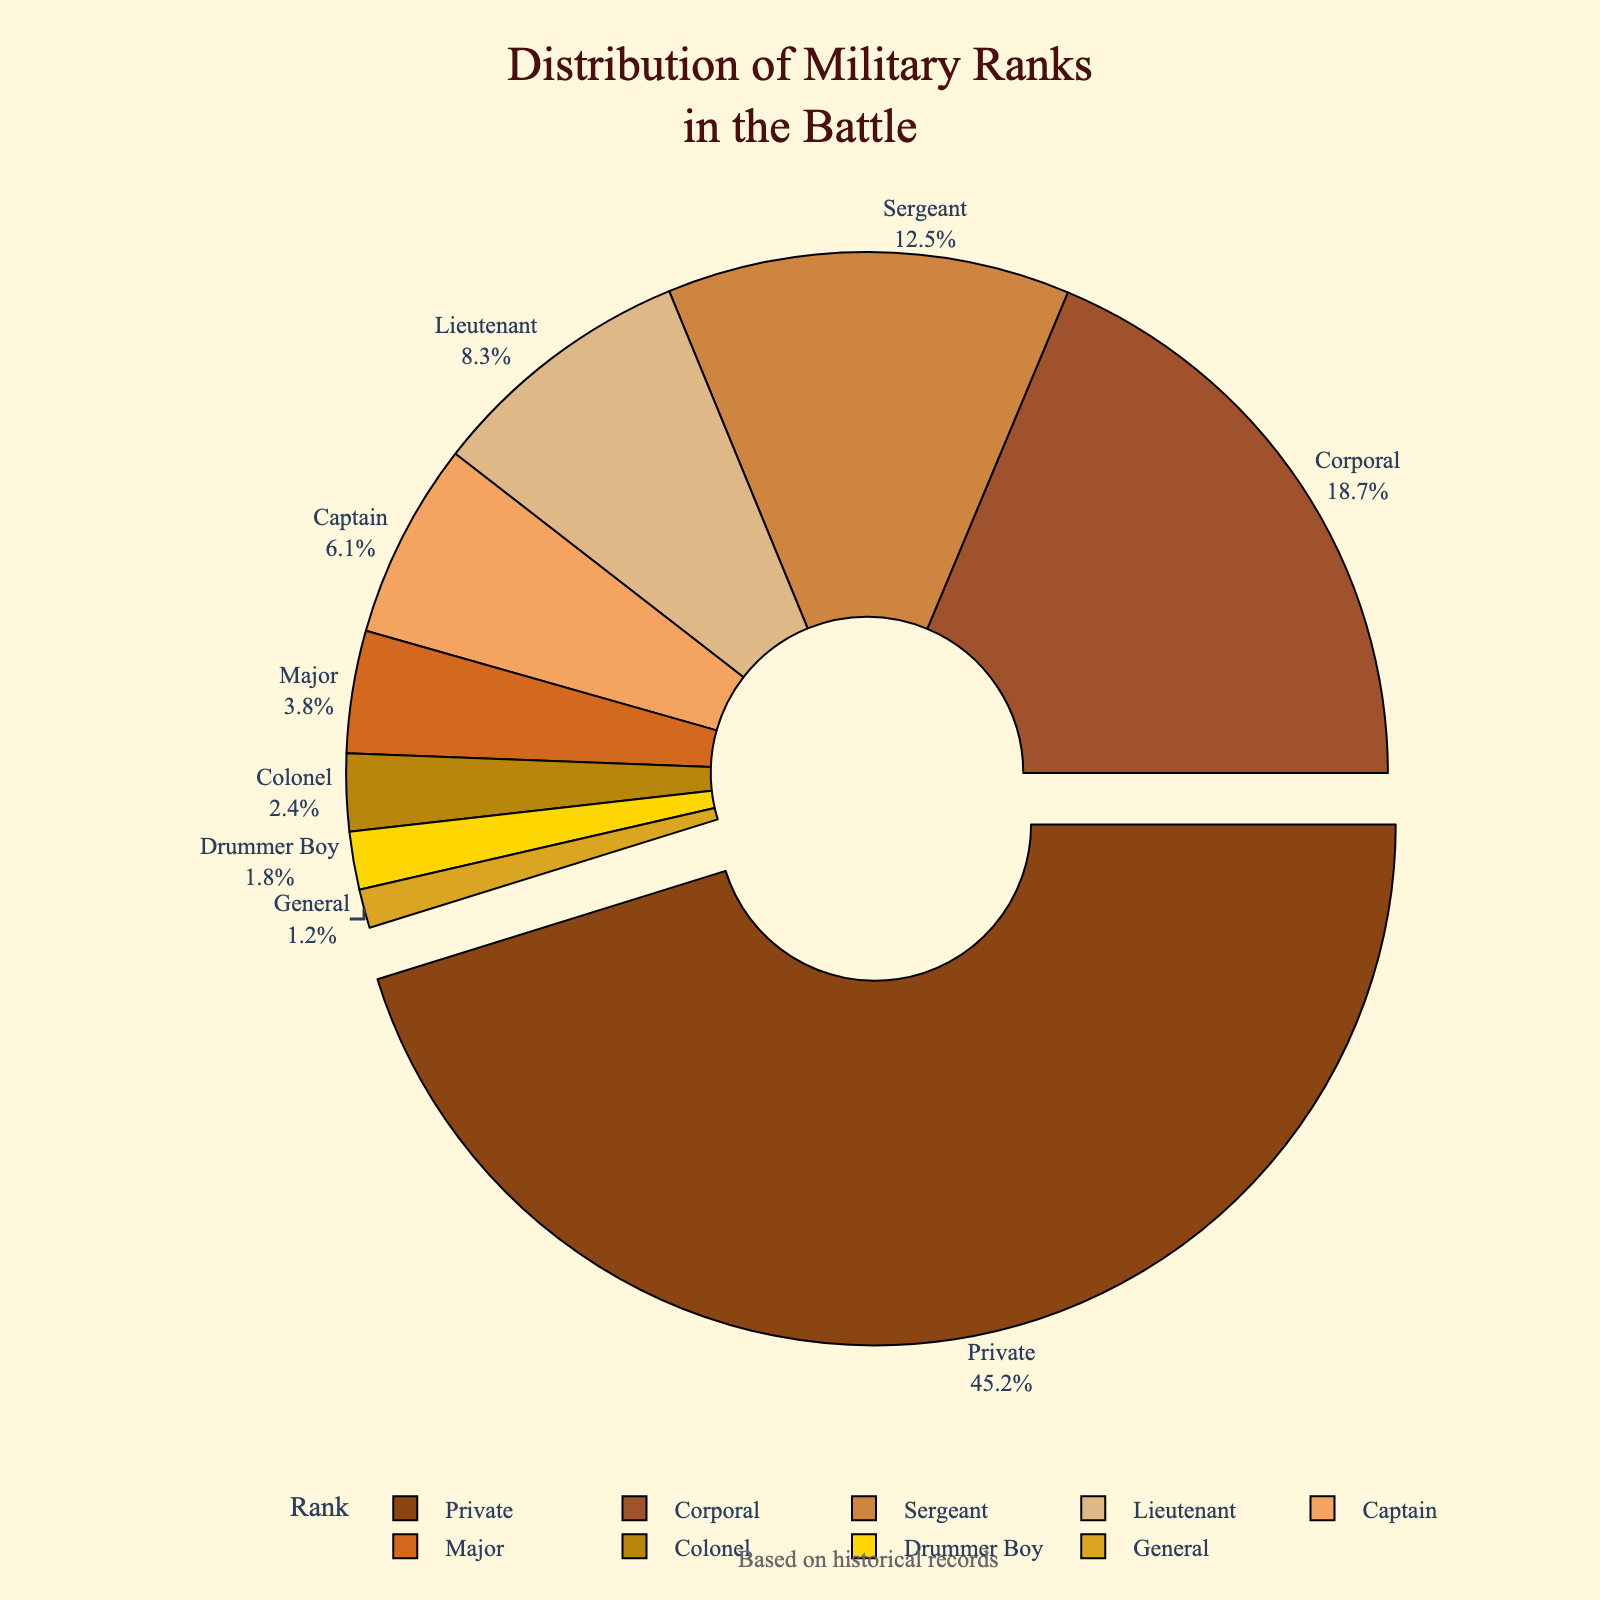Which military rank had the highest representation in the battle? The figure shows the distribution of military ranks, and the rank 'Private' is highlighted and pulled slightly out of the chart. The text next to it states 45.2%, which is the highest percentage.
Answer: Private What is the combined percentage of Corporals and Sergeants? To find the combined percentage, add the percentages of Corporals (18.7%) and Sergeants (12.5%). So, 18.7% + 12.5% = 31.2%.
Answer: 31.2% Are there more Captains or Majors? The pie chart shows Captains with a 6.1% share and Majors with a 3.8% share. Since 6.1% > 3.8%, there are more Captains than Majors.
Answer: Captains What is the sum of the percentages for officers (Lieutenant, Captain, Major, Colonel, General)? Add the percentages for these ranks: Lieutenant (8.3%), Captain (6.1%), Major (3.8%), Colonel (2.4%), and General (1.2%). So, 8.3% + 6.1% + 3.8% + 2.4% + 1.2% = 21.8%.
Answer: 21.8% Which rank has the smallest representation in the battle? The pie chart shows that 'General' has a percentage of 1.2%, which is the smallest percentage among all the ranks listed.
Answer: General Is the percentage of Drummer Boys more than that of Colonels? The chart indicates that Drummer Boys account for 1.8% and Colonels for 2.4%. Since 1.8% < 2.4%, the percentage of Drummer Boys is less than that of Colonels.
Answer: No What is the difference between the percentage of Privates and the total percentage of all officer ranks combined? The percentage of Privates is 45.2%. The total percentage of officer ranks (Lieutenant, Captain, Major, Colonel, and General) is calculated as 21.8%. The difference is 45.2% - 21.8% = 23.4%.
Answer: 23.4% What visual element indicates the rank with the highest representation? The pie chart highlights the rank 'Private' by pulling it slightly out from the rest of the pie, and it is the only rank with this visual treatment, making it stand out.
Answer: A pulled-out segment 